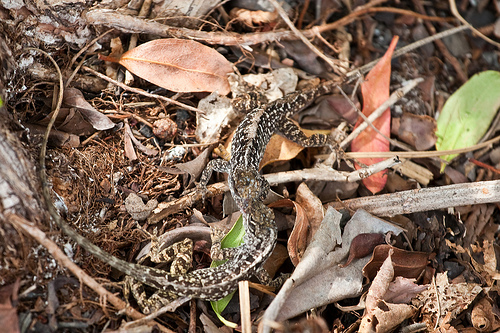<image>
Can you confirm if the lizard is under the foliage? No. The lizard is not positioned under the foliage. The vertical relationship between these objects is different. 